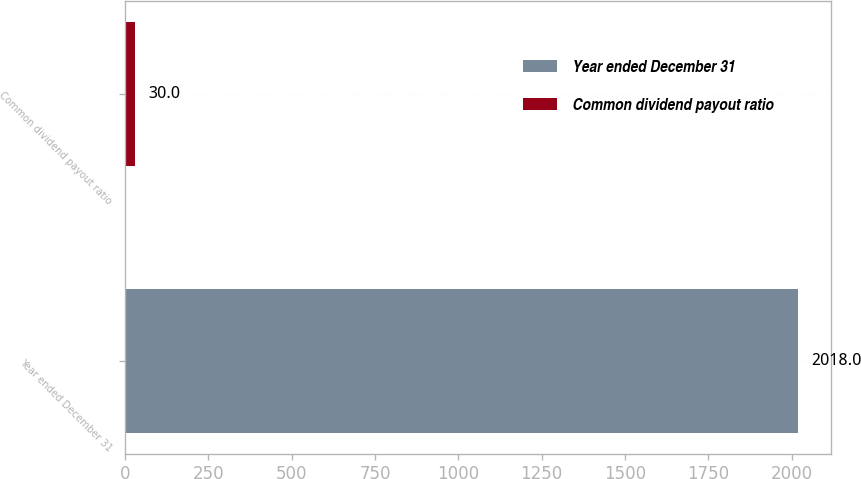Convert chart to OTSL. <chart><loc_0><loc_0><loc_500><loc_500><bar_chart><fcel>Year ended December 31<fcel>Common dividend payout ratio<nl><fcel>2018<fcel>30<nl></chart> 